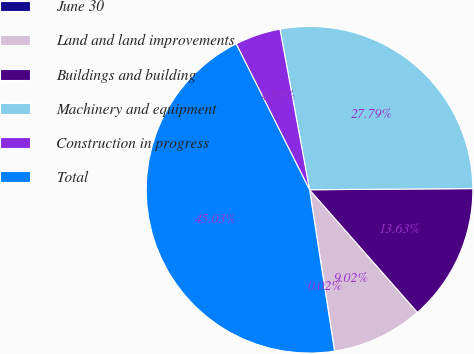<chart> <loc_0><loc_0><loc_500><loc_500><pie_chart><fcel>June 30<fcel>Land and land improvements<fcel>Buildings and building<fcel>Machinery and equipment<fcel>Construction in progress<fcel>Total<nl><fcel>0.02%<fcel>9.02%<fcel>13.63%<fcel>27.79%<fcel>4.52%<fcel>45.03%<nl></chart> 